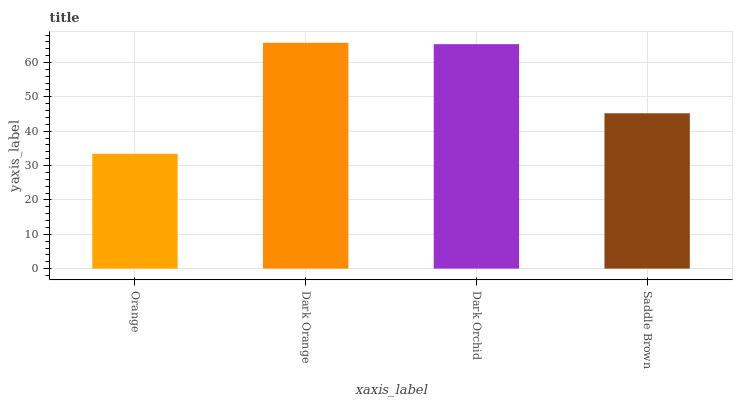Is Orange the minimum?
Answer yes or no. Yes. Is Dark Orange the maximum?
Answer yes or no. Yes. Is Dark Orchid the minimum?
Answer yes or no. No. Is Dark Orchid the maximum?
Answer yes or no. No. Is Dark Orange greater than Dark Orchid?
Answer yes or no. Yes. Is Dark Orchid less than Dark Orange?
Answer yes or no. Yes. Is Dark Orchid greater than Dark Orange?
Answer yes or no. No. Is Dark Orange less than Dark Orchid?
Answer yes or no. No. Is Dark Orchid the high median?
Answer yes or no. Yes. Is Saddle Brown the low median?
Answer yes or no. Yes. Is Saddle Brown the high median?
Answer yes or no. No. Is Dark Orange the low median?
Answer yes or no. No. 